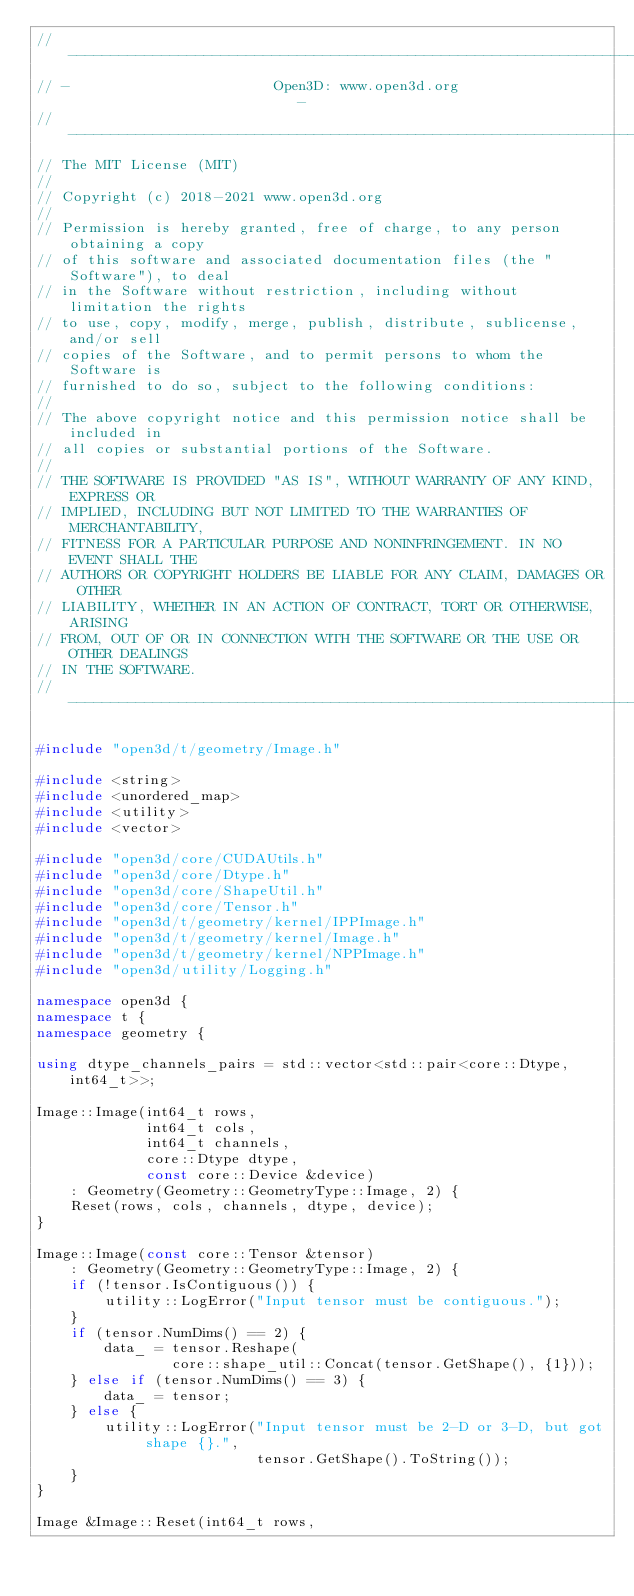Convert code to text. <code><loc_0><loc_0><loc_500><loc_500><_C++_>// ----------------------------------------------------------------------------
// -                        Open3D: www.open3d.org                            -
// ----------------------------------------------------------------------------
// The MIT License (MIT)
//
// Copyright (c) 2018-2021 www.open3d.org
//
// Permission is hereby granted, free of charge, to any person obtaining a copy
// of this software and associated documentation files (the "Software"), to deal
// in the Software without restriction, including without limitation the rights
// to use, copy, modify, merge, publish, distribute, sublicense, and/or sell
// copies of the Software, and to permit persons to whom the Software is
// furnished to do so, subject to the following conditions:
//
// The above copyright notice and this permission notice shall be included in
// all copies or substantial portions of the Software.
//
// THE SOFTWARE IS PROVIDED "AS IS", WITHOUT WARRANTY OF ANY KIND, EXPRESS OR
// IMPLIED, INCLUDING BUT NOT LIMITED TO THE WARRANTIES OF MERCHANTABILITY,
// FITNESS FOR A PARTICULAR PURPOSE AND NONINFRINGEMENT. IN NO EVENT SHALL THE
// AUTHORS OR COPYRIGHT HOLDERS BE LIABLE FOR ANY CLAIM, DAMAGES OR OTHER
// LIABILITY, WHETHER IN AN ACTION OF CONTRACT, TORT OR OTHERWISE, ARISING
// FROM, OUT OF OR IN CONNECTION WITH THE SOFTWARE OR THE USE OR OTHER DEALINGS
// IN THE SOFTWARE.
// ----------------------------------------------------------------------------

#include "open3d/t/geometry/Image.h"

#include <string>
#include <unordered_map>
#include <utility>
#include <vector>

#include "open3d/core/CUDAUtils.h"
#include "open3d/core/Dtype.h"
#include "open3d/core/ShapeUtil.h"
#include "open3d/core/Tensor.h"
#include "open3d/t/geometry/kernel/IPPImage.h"
#include "open3d/t/geometry/kernel/Image.h"
#include "open3d/t/geometry/kernel/NPPImage.h"
#include "open3d/utility/Logging.h"

namespace open3d {
namespace t {
namespace geometry {

using dtype_channels_pairs = std::vector<std::pair<core::Dtype, int64_t>>;

Image::Image(int64_t rows,
             int64_t cols,
             int64_t channels,
             core::Dtype dtype,
             const core::Device &device)
    : Geometry(Geometry::GeometryType::Image, 2) {
    Reset(rows, cols, channels, dtype, device);
}

Image::Image(const core::Tensor &tensor)
    : Geometry(Geometry::GeometryType::Image, 2) {
    if (!tensor.IsContiguous()) {
        utility::LogError("Input tensor must be contiguous.");
    }
    if (tensor.NumDims() == 2) {
        data_ = tensor.Reshape(
                core::shape_util::Concat(tensor.GetShape(), {1}));
    } else if (tensor.NumDims() == 3) {
        data_ = tensor;
    } else {
        utility::LogError("Input tensor must be 2-D or 3-D, but got shape {}.",
                          tensor.GetShape().ToString());
    }
}

Image &Image::Reset(int64_t rows,</code> 